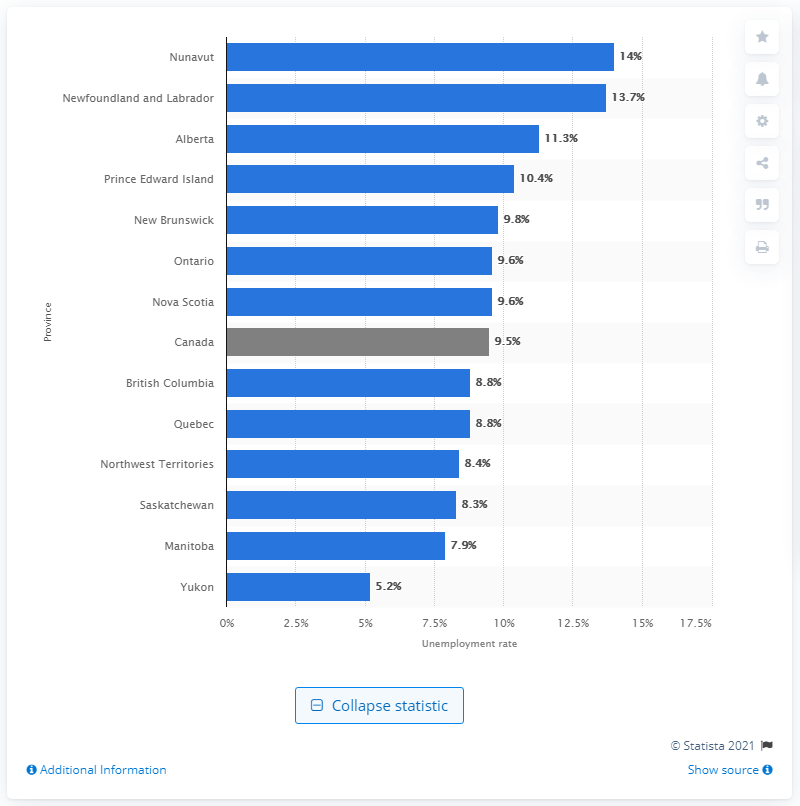Indicate a few pertinent items in this graphic. According to the data, the Yukon territory had the lowest unemployment rate in Canada. 